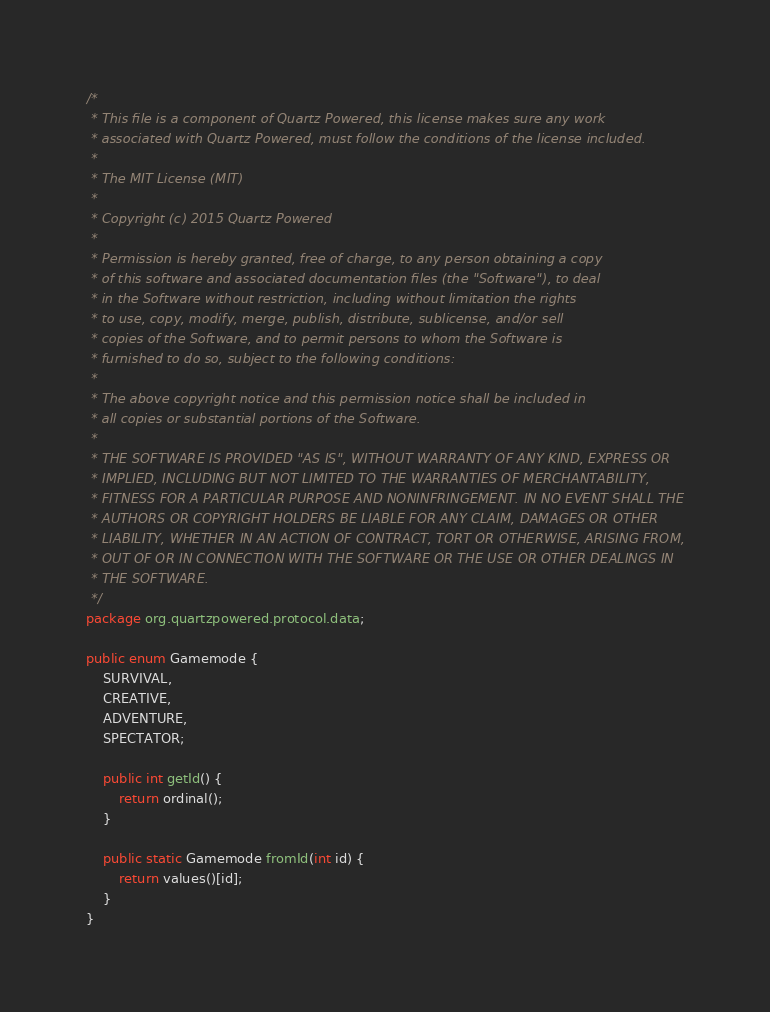Convert code to text. <code><loc_0><loc_0><loc_500><loc_500><_Java_>/*
 * This file is a component of Quartz Powered, this license makes sure any work
 * associated with Quartz Powered, must follow the conditions of the license included.
 *
 * The MIT License (MIT)
 *
 * Copyright (c) 2015 Quartz Powered
 *
 * Permission is hereby granted, free of charge, to any person obtaining a copy
 * of this software and associated documentation files (the "Software"), to deal
 * in the Software without restriction, including without limitation the rights
 * to use, copy, modify, merge, publish, distribute, sublicense, and/or sell
 * copies of the Software, and to permit persons to whom the Software is
 * furnished to do so, subject to the following conditions:
 *
 * The above copyright notice and this permission notice shall be included in
 * all copies or substantial portions of the Software.
 *
 * THE SOFTWARE IS PROVIDED "AS IS", WITHOUT WARRANTY OF ANY KIND, EXPRESS OR
 * IMPLIED, INCLUDING BUT NOT LIMITED TO THE WARRANTIES OF MERCHANTABILITY,
 * FITNESS FOR A PARTICULAR PURPOSE AND NONINFRINGEMENT. IN NO EVENT SHALL THE
 * AUTHORS OR COPYRIGHT HOLDERS BE LIABLE FOR ANY CLAIM, DAMAGES OR OTHER
 * LIABILITY, WHETHER IN AN ACTION OF CONTRACT, TORT OR OTHERWISE, ARISING FROM,
 * OUT OF OR IN CONNECTION WITH THE SOFTWARE OR THE USE OR OTHER DEALINGS IN
 * THE SOFTWARE.
 */
package org.quartzpowered.protocol.data;

public enum Gamemode {
    SURVIVAL,
    CREATIVE,
    ADVENTURE,
    SPECTATOR;

    public int getId() {
        return ordinal();
    }

    public static Gamemode fromId(int id) {
        return values()[id];
    }
}
</code> 